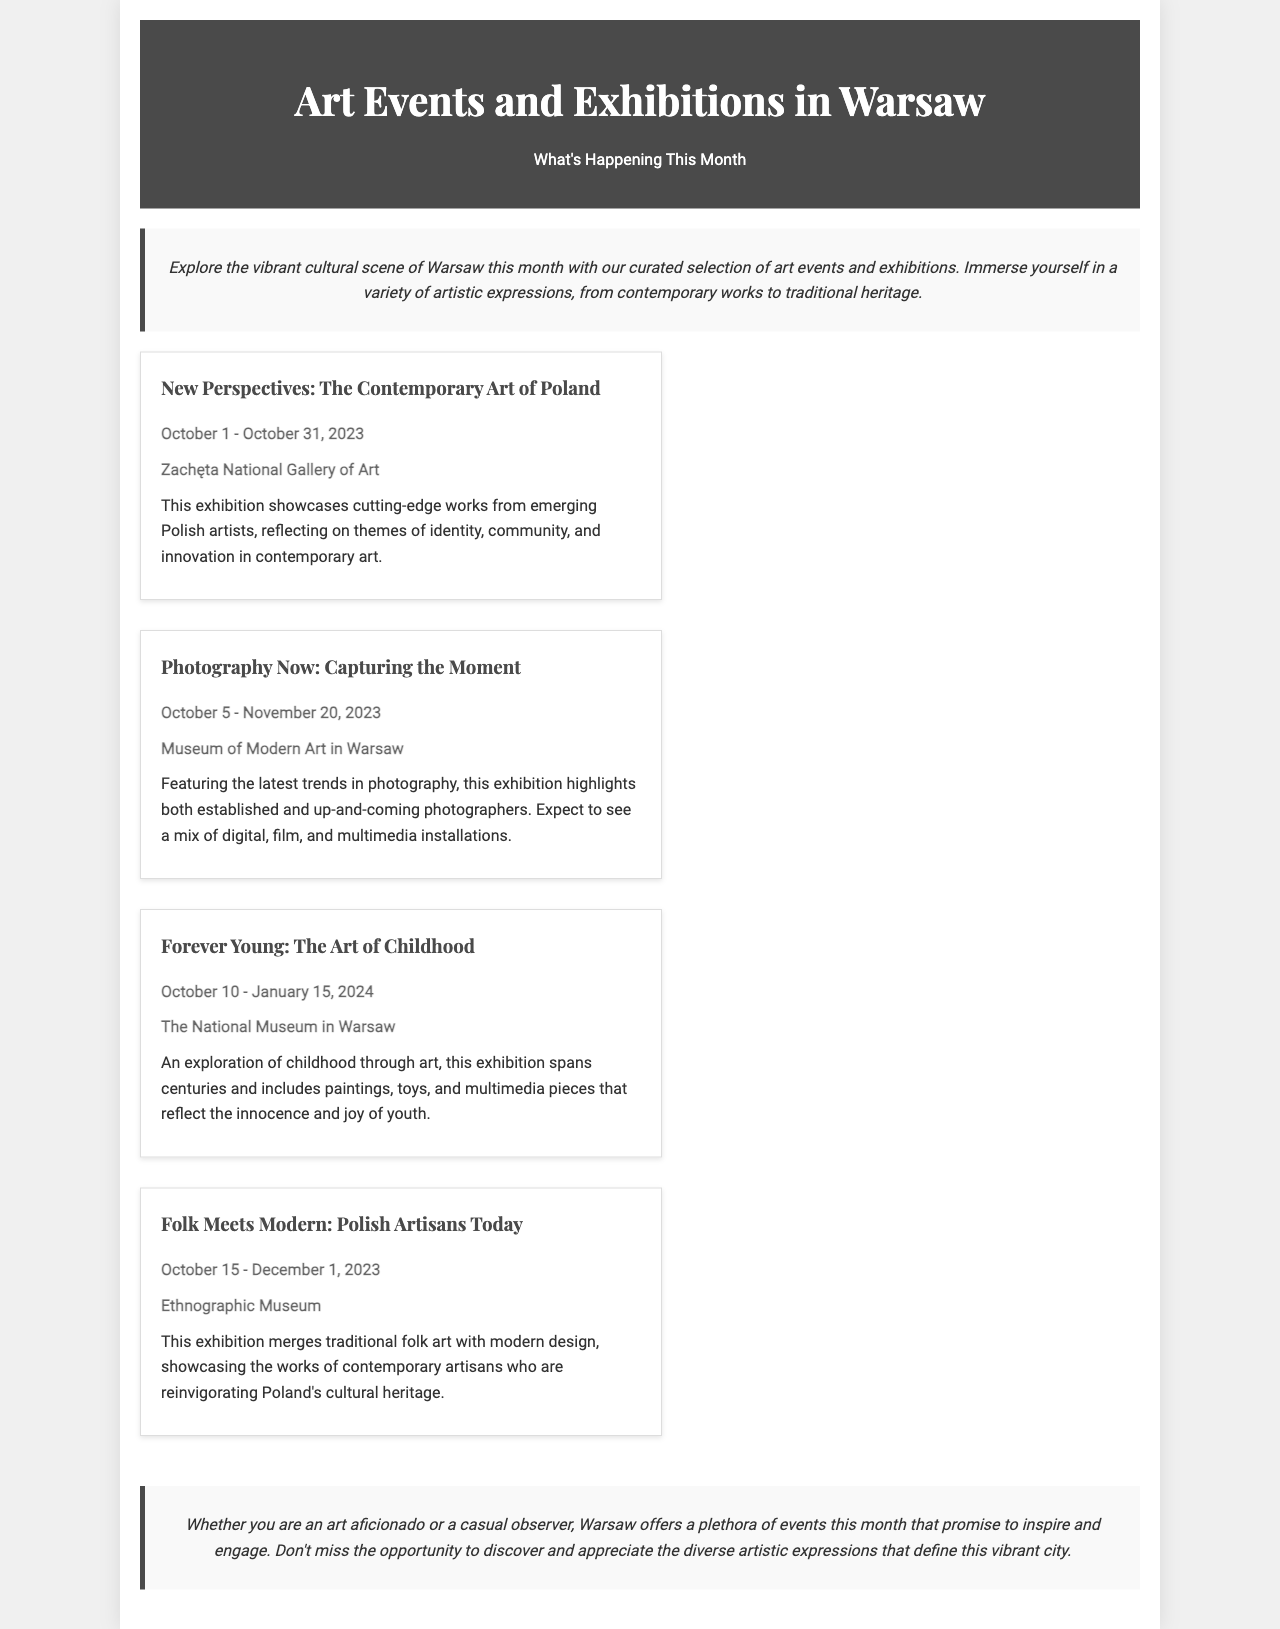what is the title of the exhibition featuring emerging Polish artists? The title of the exhibition is mentioned as "New Perspectives: The Contemporary Art of Poland."
Answer: New Perspectives: The Contemporary Art of Poland what is the date range for the "Photography Now" exhibition? The date range for the "Photography Now" exhibition is specified as October 5 - November 20, 2023.
Answer: October 5 - November 20, 2023 where is the "Forever Young" exhibition held? The location for the "Forever Young" exhibition is indicated as The National Museum in Warsaw.
Answer: The National Museum in Warsaw how many events are listed in the document? The number of events is the total of the exhibitions listed, which includes four separate events.
Answer: 4 which exhibition explores themes of childhood through art? The exhibition that explores themes of childhood is called "Forever Young: The Art of Childhood."
Answer: Forever Young: The Art of Childhood what is the duration of the "Folk Meets Modern" exhibition? The duration can be calculated from the start date to the end date mentioned, which is October 15 - December 1, 2023.
Answer: October 15 - December 1, 2023 what is the main theme of the "Folk Meets Modern" exhibition? The main theme is outlined as merging traditional folk art with modern design.
Answer: Merging traditional folk art with modern design what type of art does the "Photography Now" exhibition include? The types of art included are specified as digital, film, and multimedia installations.
Answer: Digital, film, and multimedia installations who is the intended audience for these art events? The intended audience is referred to as both art aficionados and casual observers.
Answer: Art aficionados and casual observers 